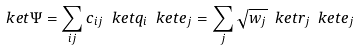<formula> <loc_0><loc_0><loc_500><loc_500>\ k e t { \Psi } = \sum _ { i j } c _ { i j } \ k e t { q _ { i } } \ k e t { e _ { j } } = \sum _ { j } \sqrt { w _ { j } } \ k e t { r _ { j } } \ k e t { e _ { j } }</formula> 